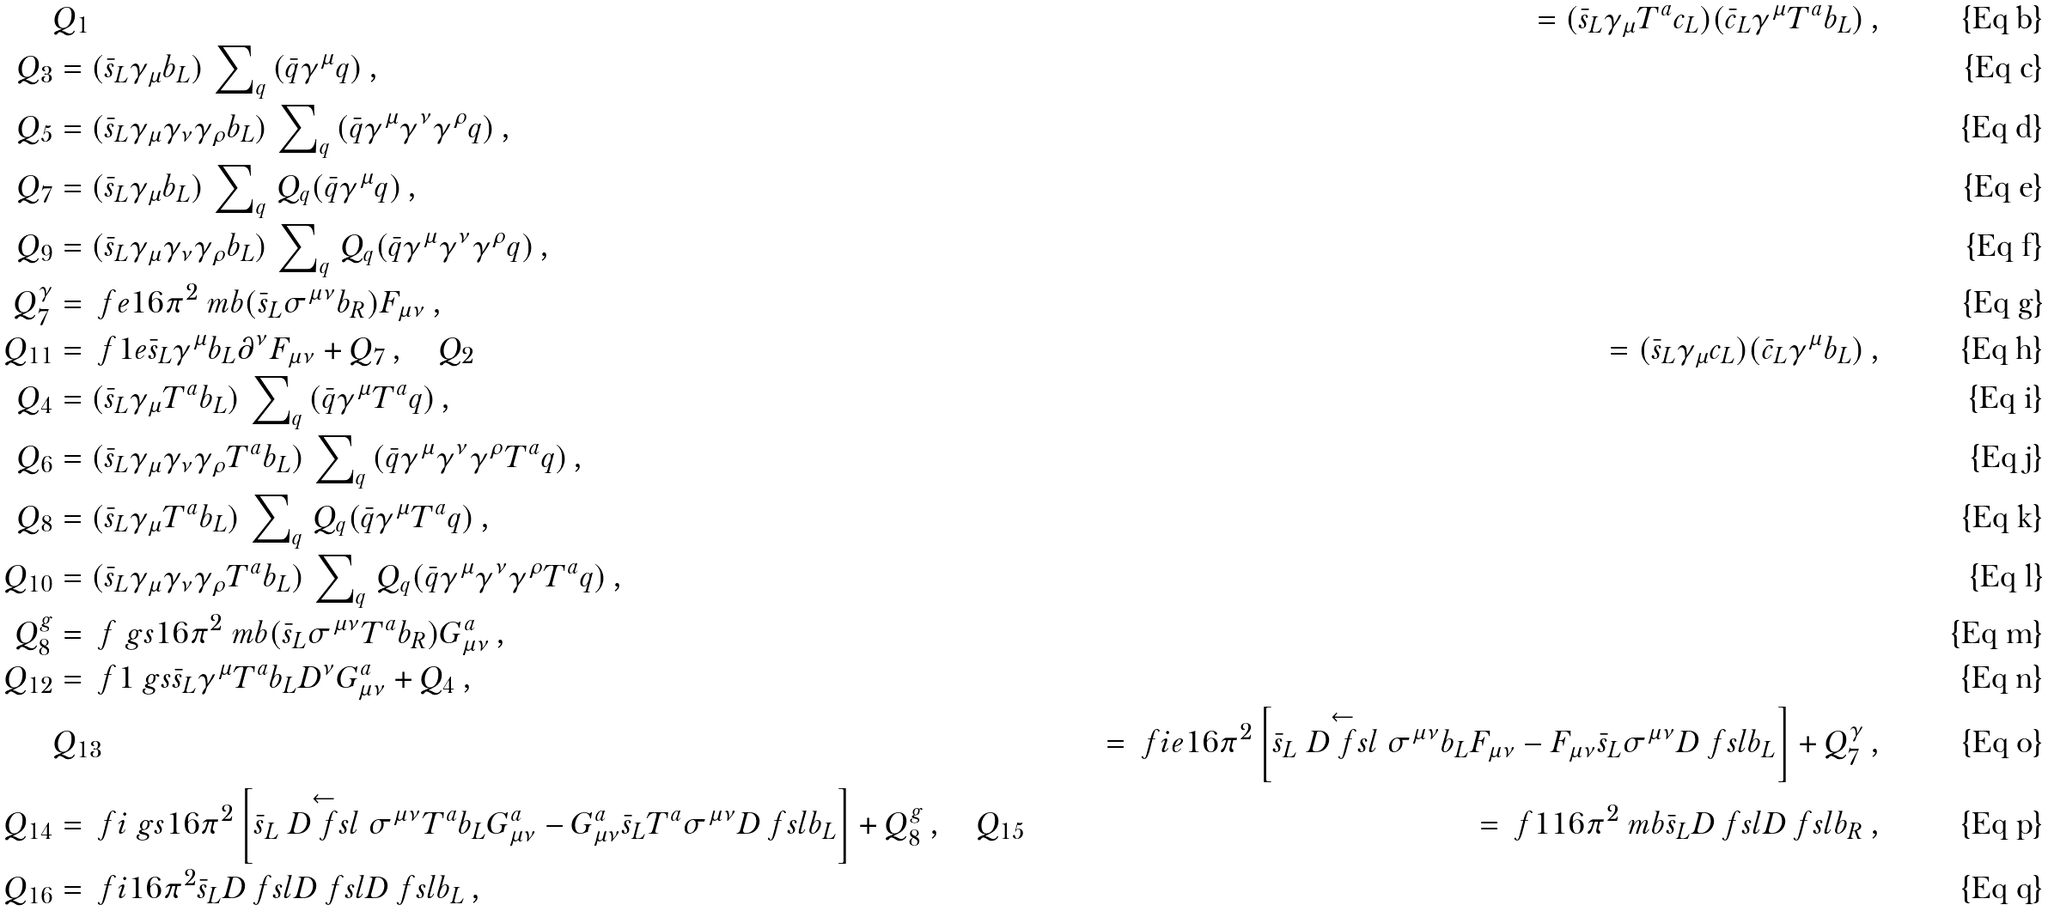<formula> <loc_0><loc_0><loc_500><loc_500>& Q _ { 1 } & = ( \bar { s } _ { L } \gamma _ { \mu } T ^ { a } c _ { L } ) ( \bar { c } _ { L } \gamma ^ { \mu } T ^ { a } b _ { L } ) \, , \\ Q _ { 3 } & = ( \bar { s } _ { L } \gamma _ { \mu } b _ { L } ) \, \sum \nolimits _ { q } \, ( \bar { q } \gamma ^ { \mu } q ) \, , \\ Q _ { 5 } & = ( \bar { s } _ { L } \gamma _ { \mu } \gamma _ { \nu } \gamma _ { \rho } b _ { L } ) \, \sum \nolimits _ { q } \, ( \bar { q } \gamma ^ { \mu } \gamma ^ { \nu } \gamma ^ { \rho } q ) \, , \\ Q _ { 7 } & = ( \bar { s } _ { L } \gamma _ { \mu } b _ { L } ) \, \sum \nolimits _ { q } \, Q _ { q } ( \bar { q } \gamma ^ { \mu } q ) \, , \\ Q _ { 9 } & = ( \bar { s } _ { L } \gamma _ { \mu } \gamma _ { \nu } \gamma _ { \rho } b _ { L } ) \, \sum \nolimits _ { q } \, Q _ { q } ( \bar { q } \gamma ^ { \mu } \gamma ^ { \nu } \gamma ^ { \rho } q ) \, , \\ Q _ { 7 } ^ { \gamma } & = \ f { e } { 1 6 \pi ^ { 2 } } \ m b ( \bar { s } _ { L } \sigma ^ { \mu \nu } b _ { R } ) F _ { \mu \nu } \, , \\ Q _ { 1 1 } & = \ f { 1 } { e } \bar { s } _ { L } \gamma ^ { \mu } b _ { L } \partial ^ { \nu } F _ { \mu \nu } + Q _ { 7 } \, , \quad Q _ { 2 } & = ( \bar { s } _ { L } \gamma _ { \mu } c _ { L } ) ( \bar { c } _ { L } \gamma ^ { \mu } b _ { L } ) \, , \\ Q _ { 4 } & = ( \bar { s } _ { L } \gamma _ { \mu } T ^ { a } b _ { L } ) \, \sum \nolimits _ { q } \, ( \bar { q } \gamma ^ { \mu } T ^ { a } q ) \, , \\ Q _ { 6 } & = ( \bar { s } _ { L } \gamma _ { \mu } \gamma _ { \nu } \gamma _ { \rho } T ^ { a } b _ { L } ) \, \sum \nolimits _ { q } \, ( \bar { q } \gamma ^ { \mu } \gamma ^ { \nu } \gamma ^ { \rho } T ^ { a } q ) \, , \\ Q _ { 8 } & = ( \bar { s } _ { L } \gamma _ { \mu } T ^ { a } b _ { L } ) \, \sum \nolimits _ { q } \, Q _ { q } ( \bar { q } \gamma ^ { \mu } T ^ { a } q ) \, , \\ Q _ { 1 0 } & = ( \bar { s } _ { L } \gamma _ { \mu } \gamma _ { \nu } \gamma _ { \rho } T ^ { a } b _ { L } ) \, \sum \nolimits _ { q } \, Q _ { q } ( \bar { q } \gamma ^ { \mu } \gamma ^ { \nu } \gamma ^ { \rho } T ^ { a } q ) \, , \\ Q _ { 8 } ^ { g } & = \ f { \ g s } { 1 6 \pi ^ { 2 } } \ m b ( \bar { s } _ { L } \sigma ^ { \mu \nu } T ^ { a } b _ { R } ) G _ { \mu \nu } ^ { a } \, , \\ Q _ { 1 2 } & = \ f { 1 } { \ g s } \bar { s } _ { L } \gamma ^ { \mu } T ^ { a } b _ { L } D ^ { \nu } G _ { \mu \nu } ^ { a } + Q _ { 4 } \, , \\ & Q _ { 1 3 } & = \ f { i e } { 1 6 \pi ^ { 2 } } \left [ \bar { s } _ { L } \stackrel { \leftarrow } { D \ f s l } \sigma ^ { \mu \nu } b _ { L } F _ { \mu \nu } - F _ { \mu \nu } \bar { s } _ { L } \sigma ^ { \mu \nu } D \ f s l b _ { L } \right ] + Q _ { 7 } ^ { \gamma } \, , \\ Q _ { 1 4 } & = \ f { i \ g s } { 1 6 \pi ^ { 2 } } \left [ \bar { s } _ { L } \stackrel { \leftarrow } { D \ f s l } \sigma ^ { \mu \nu } T ^ { a } b _ { L } G _ { \mu \nu } ^ { a } - G _ { \mu \nu } ^ { a } \bar { s } _ { L } T ^ { a } \sigma ^ { \mu \nu } D \ f s l b _ { L } \right ] + Q _ { 8 } ^ { g } \, , \quad Q _ { 1 5 } & = \ f { 1 } { 1 6 \pi ^ { 2 } } \ m b \bar { s } _ { L } D \ f s l D \ f s l b _ { R } \, , \\ Q _ { 1 6 } & = \ f { i } { 1 6 \pi ^ { 2 } } \bar { s } _ { L } D \ f s l D \ f s l D \ f s l b _ { L } \, ,</formula> 